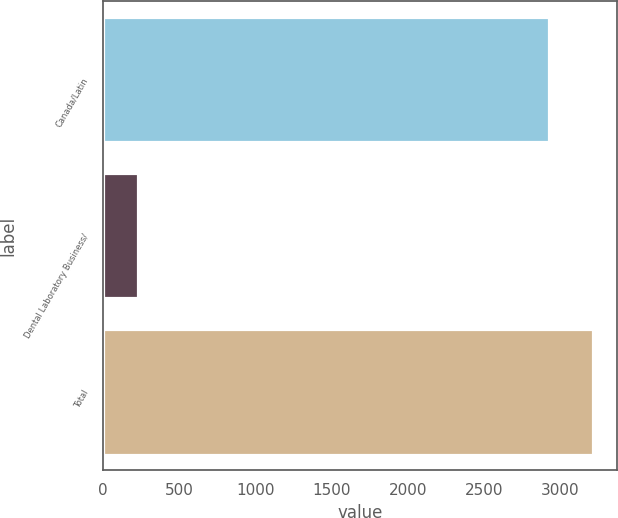Convert chart. <chart><loc_0><loc_0><loc_500><loc_500><bar_chart><fcel>Canada/Latin<fcel>Dental Laboratory Business/<fcel>Total<nl><fcel>2926<fcel>228<fcel>3213.7<nl></chart> 